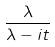Convert formula to latex. <formula><loc_0><loc_0><loc_500><loc_500>\frac { \lambda } { \lambda - i t }</formula> 